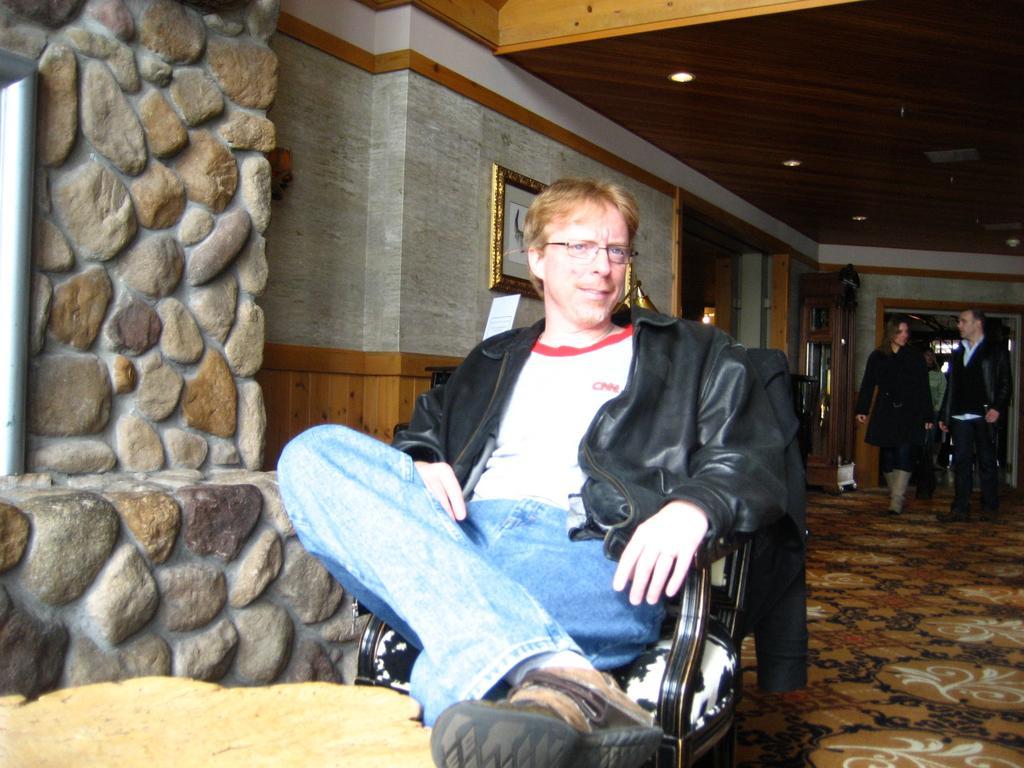Can you describe this image briefly? In this image i can see a person sitting on a chair, wearing a jacket. In the background i can see few people walking, a wall and a photo frame attached to it. 